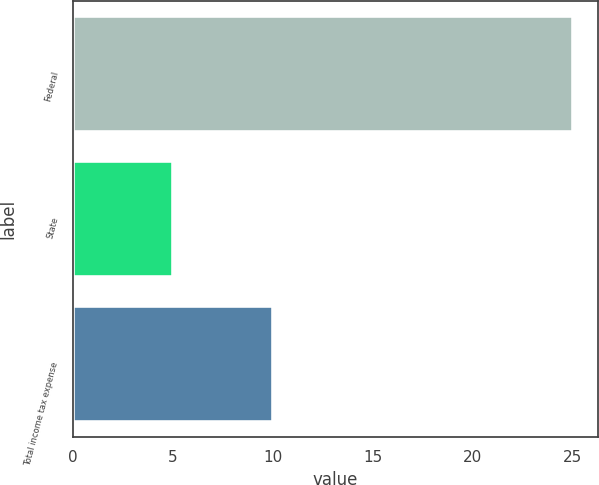<chart> <loc_0><loc_0><loc_500><loc_500><bar_chart><fcel>Federal<fcel>State<fcel>Total income tax expense<nl><fcel>25<fcel>5<fcel>10<nl></chart> 